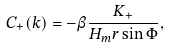<formula> <loc_0><loc_0><loc_500><loc_500>C _ { + } ( k ) = - \beta \frac { K _ { + } } { H _ { m } r \sin \Phi } ,</formula> 